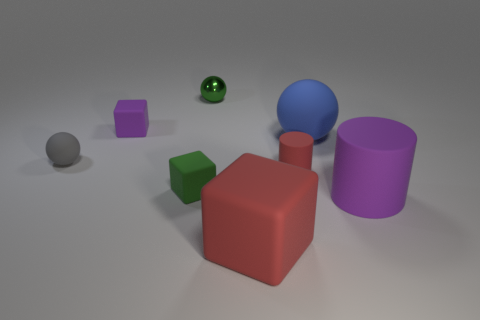Subtract all red blocks. How many blocks are left? 2 Subtract all gray balls. How many balls are left? 2 Subtract all balls. How many objects are left? 5 Subtract 3 cubes. How many cubes are left? 0 Subtract all rubber cubes. Subtract all big red shiny balls. How many objects are left? 5 Add 4 small metal spheres. How many small metal spheres are left? 5 Add 5 big purple cylinders. How many big purple cylinders exist? 6 Add 1 purple blocks. How many objects exist? 9 Subtract 0 blue cylinders. How many objects are left? 8 Subtract all red spheres. Subtract all gray cylinders. How many spheres are left? 3 